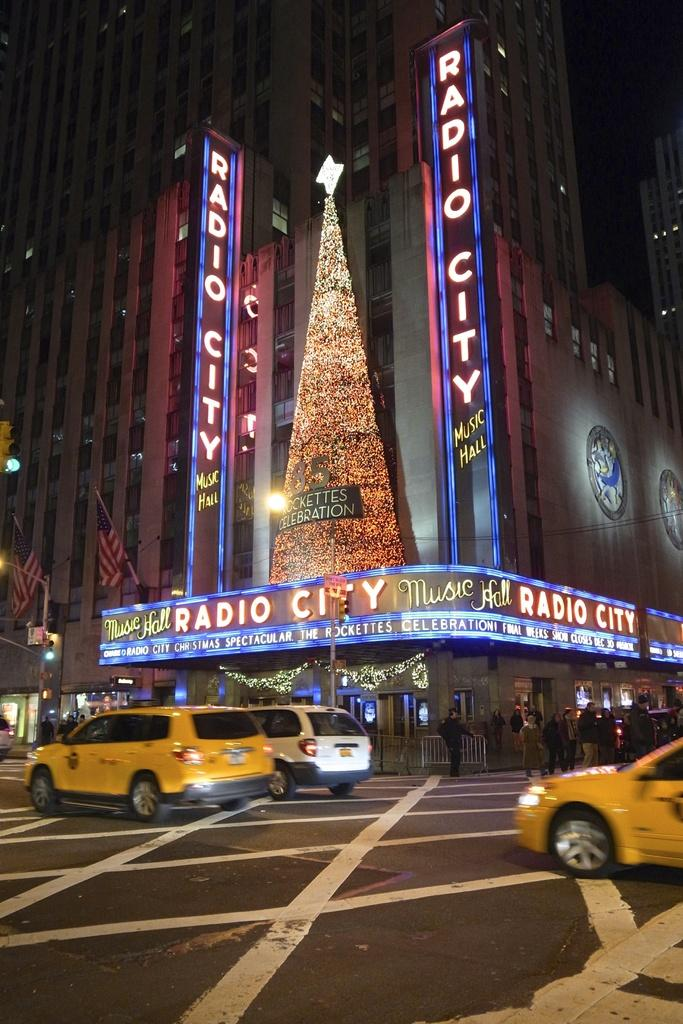<image>
Create a compact narrative representing the image presented. Taxis driving past Radio City Music Hall at night. 